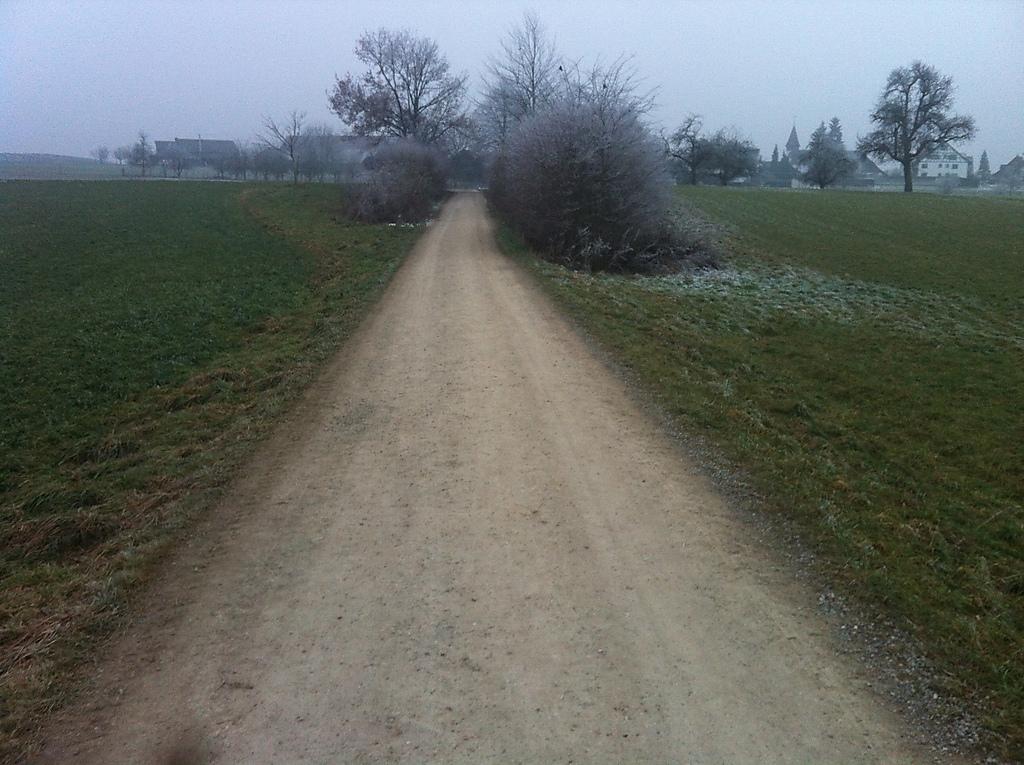Can you describe this image briefly? This image consists of grass, plants, trees, buildings and the sky. This image is taken may be near the farms. 